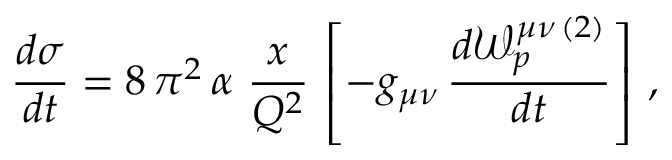<formula> <loc_0><loc_0><loc_500><loc_500>\frac { d \sigma } { d t } = 8 \, \pi ^ { 2 } \, \alpha \ \frac { x } { Q ^ { 2 } } \, \left [ - g _ { \mu \nu } \, \frac { d { \mathcal { W } } _ { p } ^ { \mu \nu \, ( 2 ) } } { d t } \right ] \, ,</formula> 